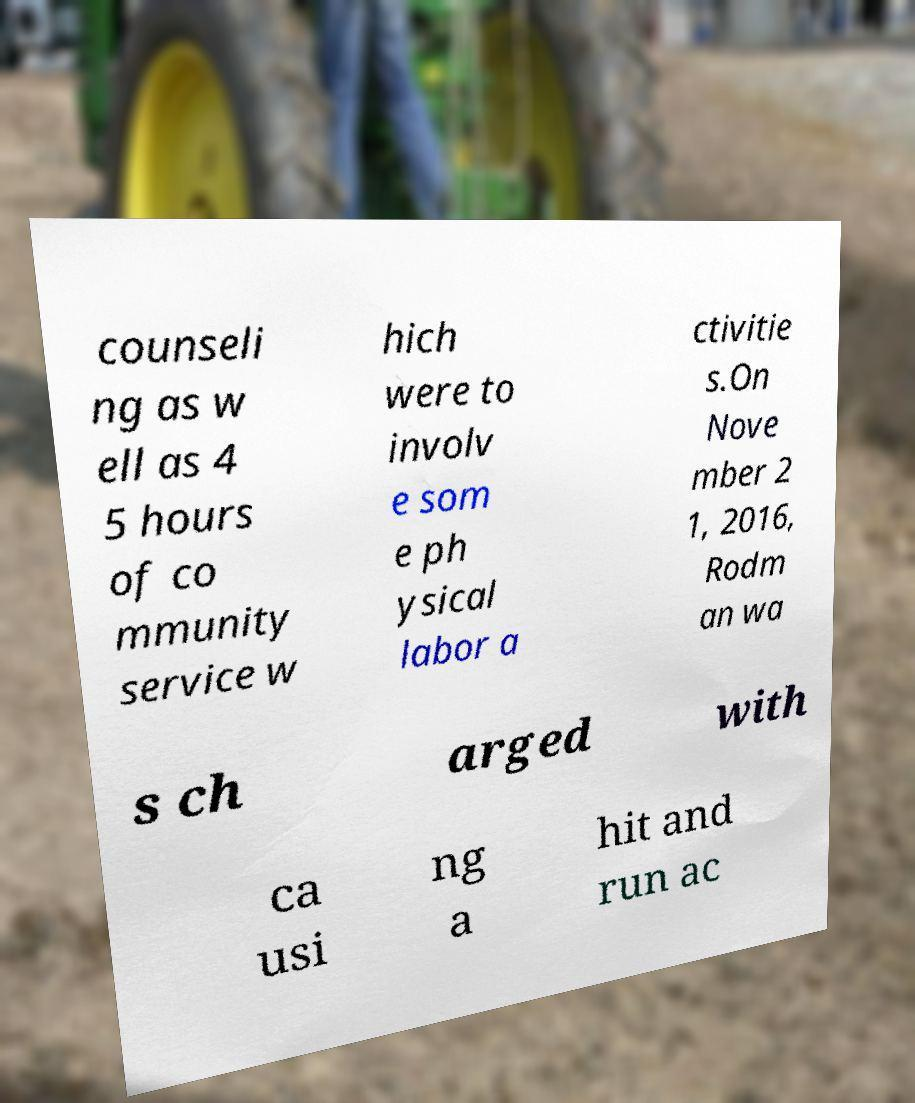Could you extract and type out the text from this image? counseli ng as w ell as 4 5 hours of co mmunity service w hich were to involv e som e ph ysical labor a ctivitie s.On Nove mber 2 1, 2016, Rodm an wa s ch arged with ca usi ng a hit and run ac 